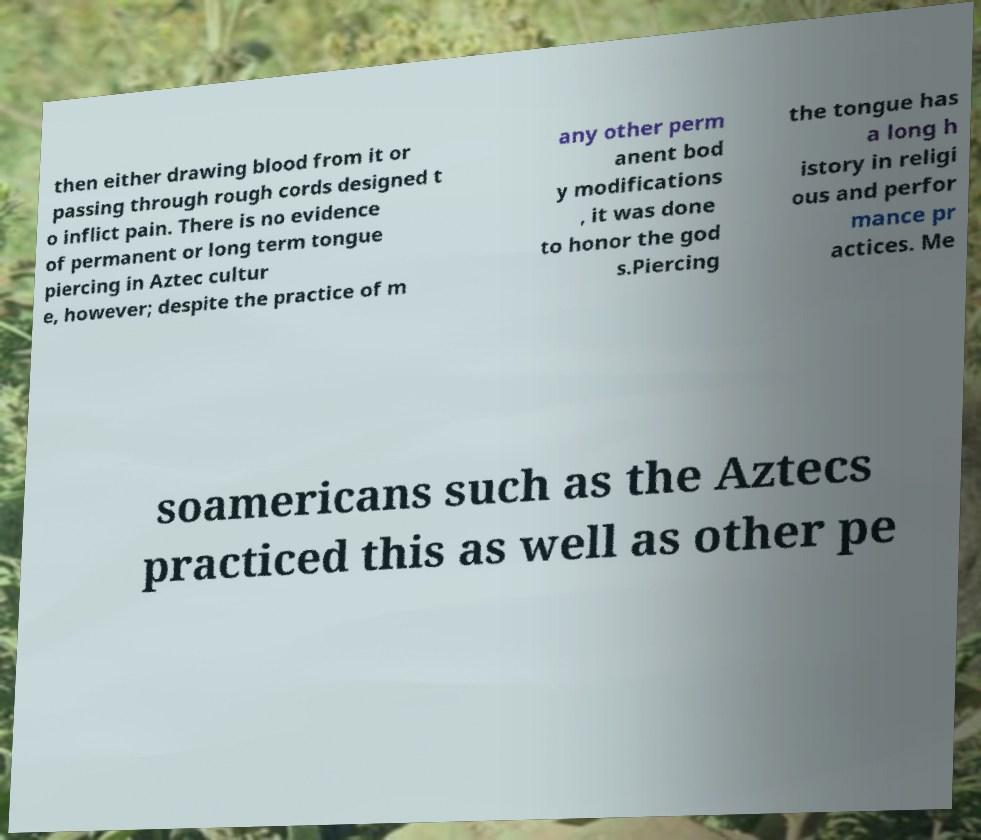There's text embedded in this image that I need extracted. Can you transcribe it verbatim? then either drawing blood from it or passing through rough cords designed t o inflict pain. There is no evidence of permanent or long term tongue piercing in Aztec cultur e, however; despite the practice of m any other perm anent bod y modifications , it was done to honor the god s.Piercing the tongue has a long h istory in religi ous and perfor mance pr actices. Me soamericans such as the Aztecs practiced this as well as other pe 